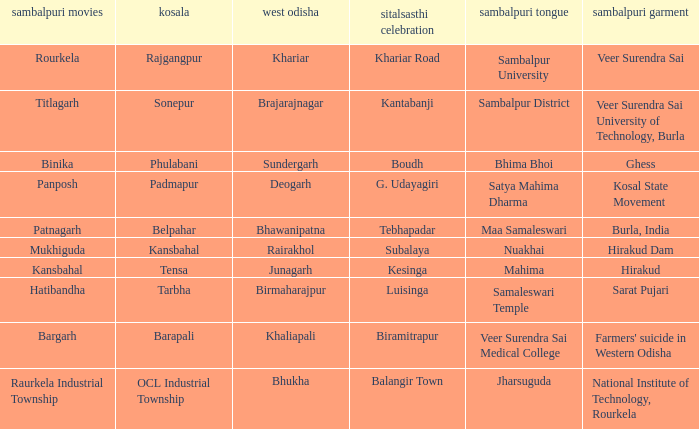What is the Kosal with a balangir town sitalsasthi carnival? OCL Industrial Township. Could you help me parse every detail presented in this table? {'header': ['sambalpuri movies', 'kosala', 'west odisha', 'sitalsasthi celebration', 'sambalpuri tongue', 'sambalpuri garment'], 'rows': [['Rourkela', 'Rajgangpur', 'Khariar', 'Khariar Road', 'Sambalpur University', 'Veer Surendra Sai'], ['Titlagarh', 'Sonepur', 'Brajarajnagar', 'Kantabanji', 'Sambalpur District', 'Veer Surendra Sai University of Technology, Burla'], ['Binika', 'Phulabani', 'Sundergarh', 'Boudh', 'Bhima Bhoi', 'Ghess'], ['Panposh', 'Padmapur', 'Deogarh', 'G. Udayagiri', 'Satya Mahima Dharma', 'Kosal State Movement'], ['Patnagarh', 'Belpahar', 'Bhawanipatna', 'Tebhapadar', 'Maa Samaleswari', 'Burla, India'], ['Mukhiguda', 'Kansbahal', 'Rairakhol', 'Subalaya', 'Nuakhai', 'Hirakud Dam'], ['Kansbahal', 'Tensa', 'Junagarh', 'Kesinga', 'Mahima', 'Hirakud'], ['Hatibandha', 'Tarbha', 'Birmaharajpur', 'Luisinga', 'Samaleswari Temple', 'Sarat Pujari'], ['Bargarh', 'Barapali', 'Khaliapali', 'Biramitrapur', 'Veer Surendra Sai Medical College', "Farmers' suicide in Western Odisha"], ['Raurkela Industrial Township', 'OCL Industrial Township', 'Bhukha', 'Balangir Town', 'Jharsuguda', 'National Institute of Technology, Rourkela']]} 